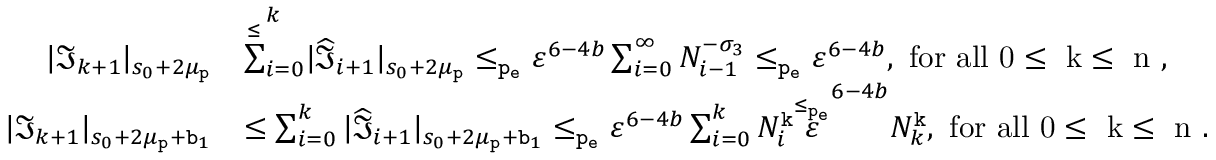<formula> <loc_0><loc_0><loc_500><loc_500>\begin{array} { r l } { | \mathfrak { I } _ { k + 1 } | _ { s _ { 0 } + 2 \mu _ { p } } } & { \overset { \leq } { \sum } _ { i = 0 } ^ { k } | \widehat { \mathfrak { I } } _ { i + 1 } | _ { s _ { 0 } + 2 \mu _ { p } } \leq _ { p _ { e } } \varepsilon ^ { 6 - 4 b } \sum _ { i = 0 } ^ { \infty } N _ { i - 1 } ^ { - \sigma _ { 3 } } \leq _ { p _ { e } } \varepsilon ^ { 6 - 4 b } , f o r a l l 0 \leq k \leq n , } \\ { | \mathfrak { I } _ { k + 1 } | _ { s _ { 0 } + 2 \mu _ { p } + b _ { 1 } } } & { \leq \sum _ { i = 0 } ^ { k } | \widehat { \mathfrak { I } } _ { i + 1 } | _ { s _ { 0 } + 2 \mu _ { p } + b _ { 1 } } \leq _ { p _ { e } } \varepsilon ^ { 6 - 4 b } \sum _ { i = 0 } ^ { k } N _ { i } ^ { k } \overset { \leq _ { p _ { e } } } \varepsilon ^ { 6 - 4 b } N _ { k } ^ { k } , f o r a l l 0 \leq k \leq n . } \end{array}</formula> 